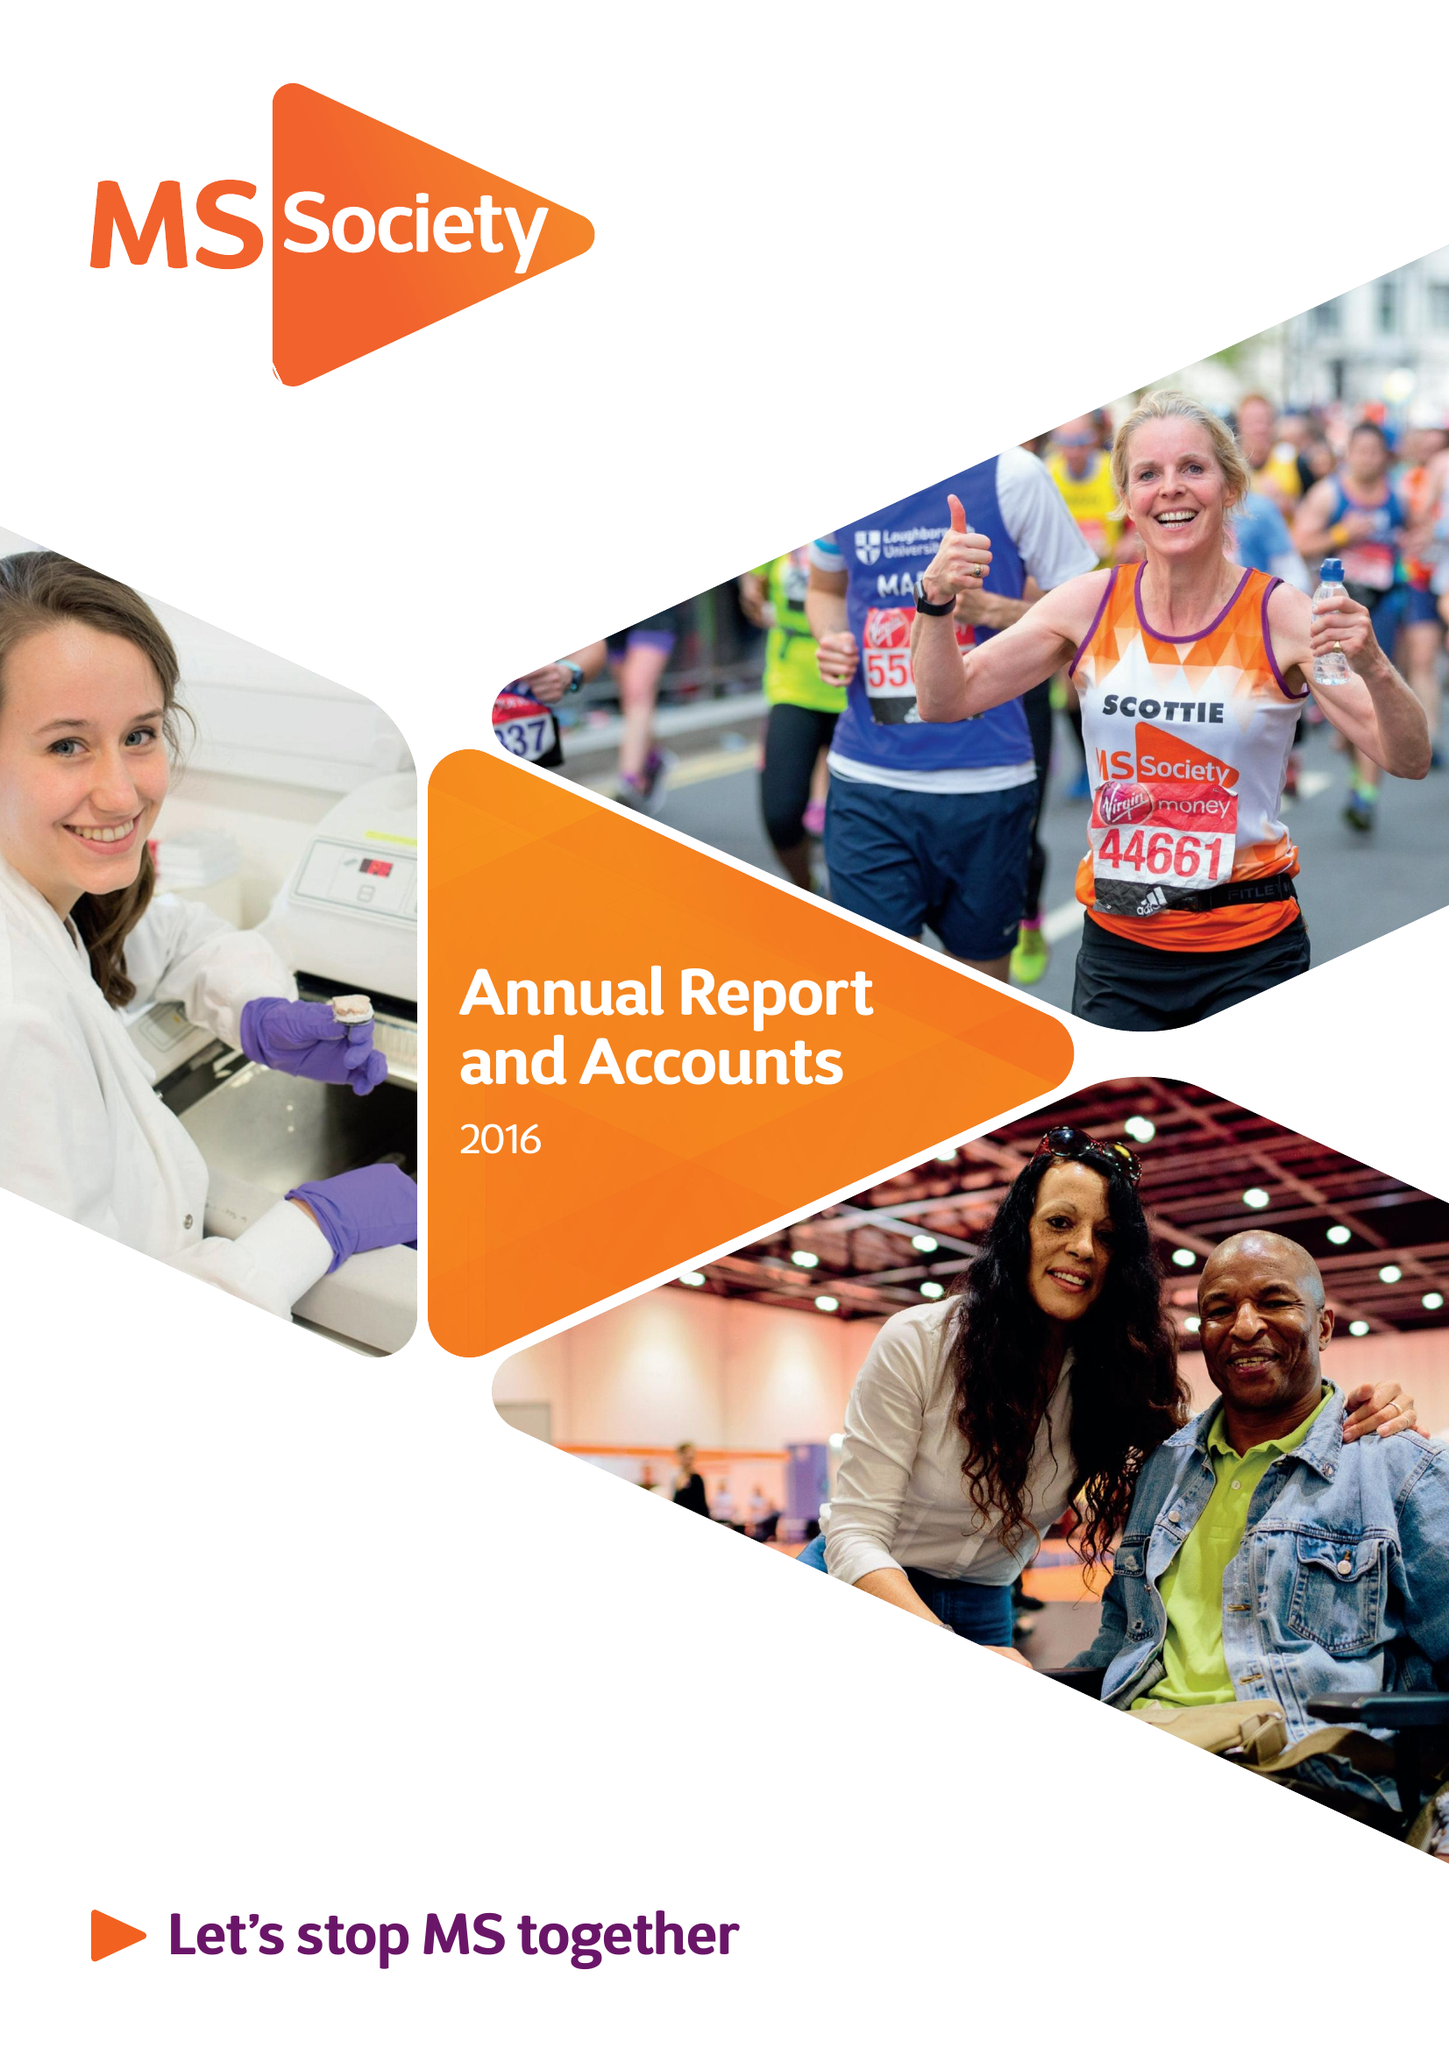What is the value for the address__post_town?
Answer the question using a single word or phrase. LONDON 